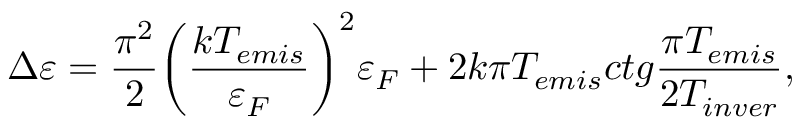<formula> <loc_0><loc_0><loc_500><loc_500>\Delta \varepsilon = \frac { { { \pi ^ { 2 } } } } { 2 } { \left ( { \frac { { k { T _ { e m i s } } } } { { { \varepsilon _ { F } } } } } \right ) ^ { 2 } } { \varepsilon _ { F } } + 2 k \pi T _ { e m i s } c t g \frac { { \pi { T _ { e m i s } } } } { { 2 { T _ { i n v e r } } } } ,</formula> 